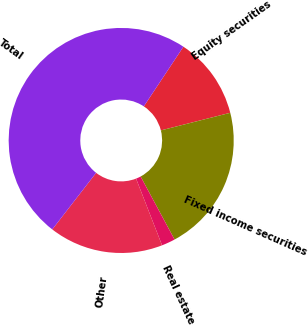<chart> <loc_0><loc_0><loc_500><loc_500><pie_chart><fcel>Equity securities<fcel>Fixed income securities<fcel>Real estate<fcel>Other<fcel>Total<nl><fcel>11.72%<fcel>21.09%<fcel>1.95%<fcel>16.41%<fcel>48.83%<nl></chart> 